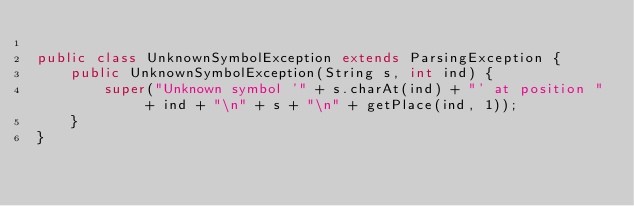Convert code to text. <code><loc_0><loc_0><loc_500><loc_500><_Java_>
public class UnknownSymbolException extends ParsingException {
    public UnknownSymbolException(String s, int ind) {
        super("Unknown symbol '" + s.charAt(ind) + "' at position " + ind + "\n" + s + "\n" + getPlace(ind, 1));
    }
}</code> 